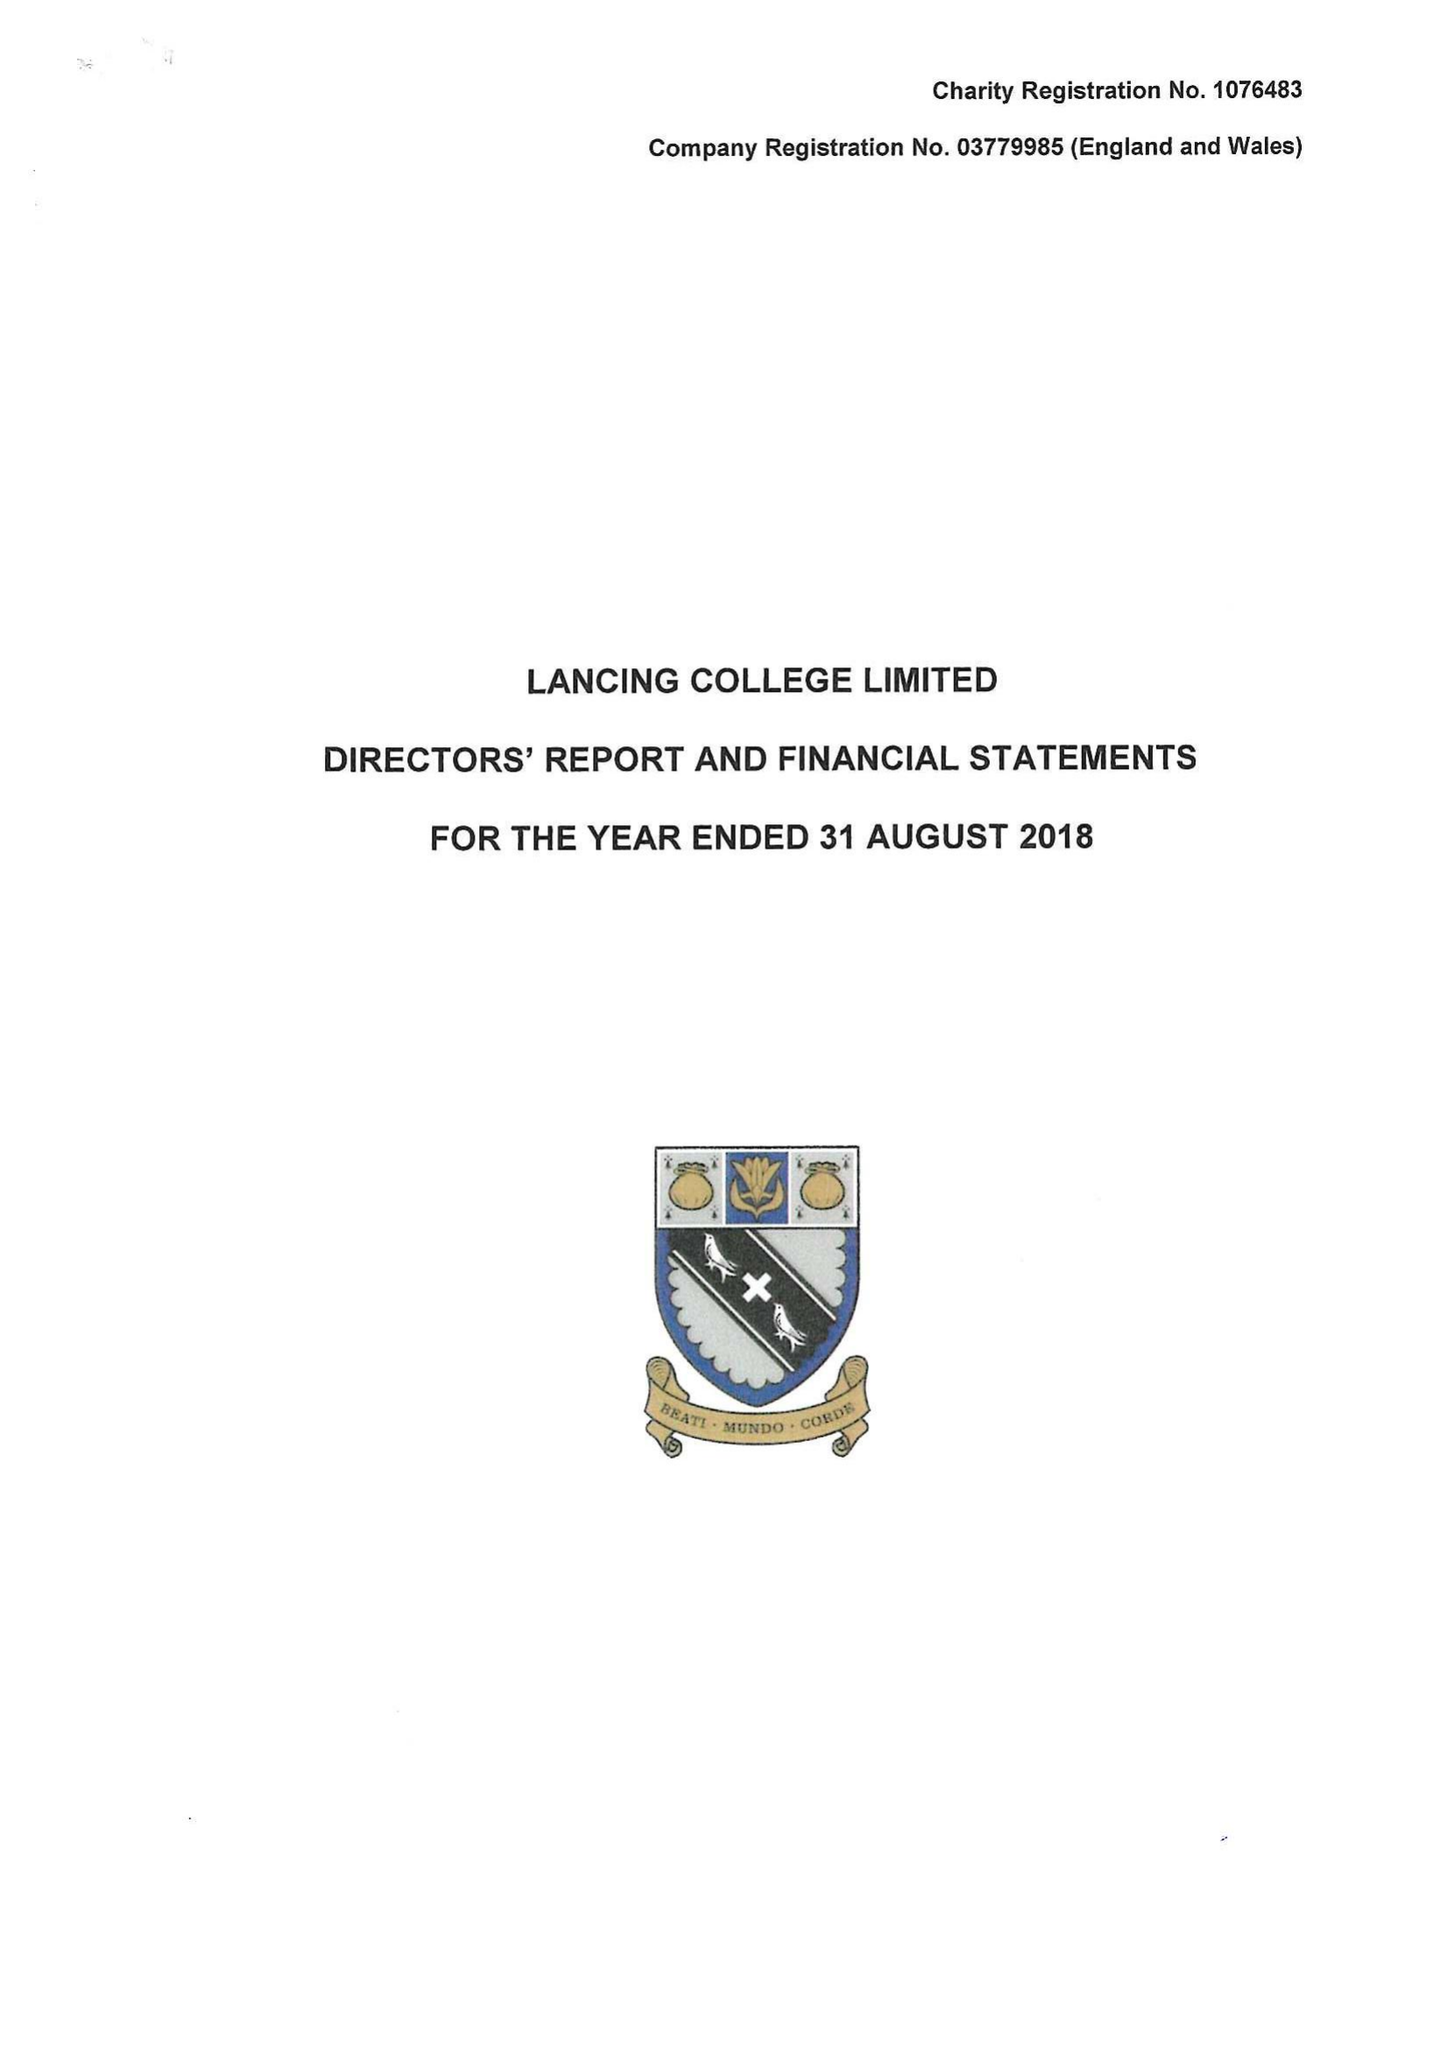What is the value for the income_annually_in_british_pounds?
Answer the question using a single word or phrase. 21908845.00 